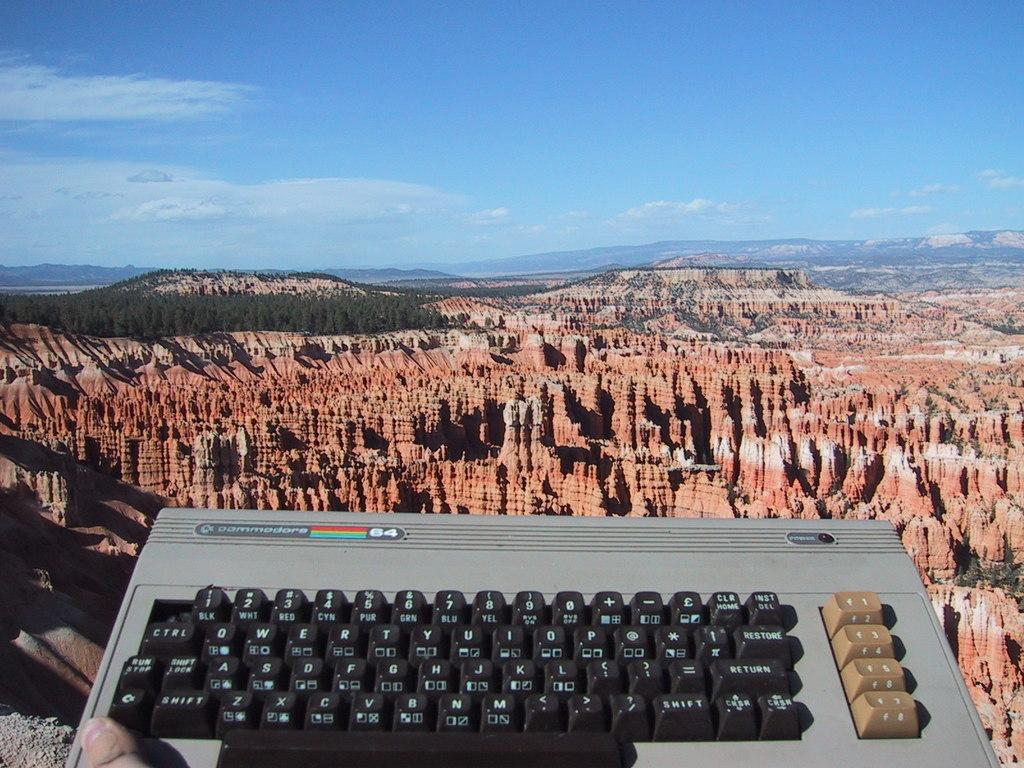<image>
Summarize the visual content of the image. A Commodore keyboard is displayed in front of a large canyon. 